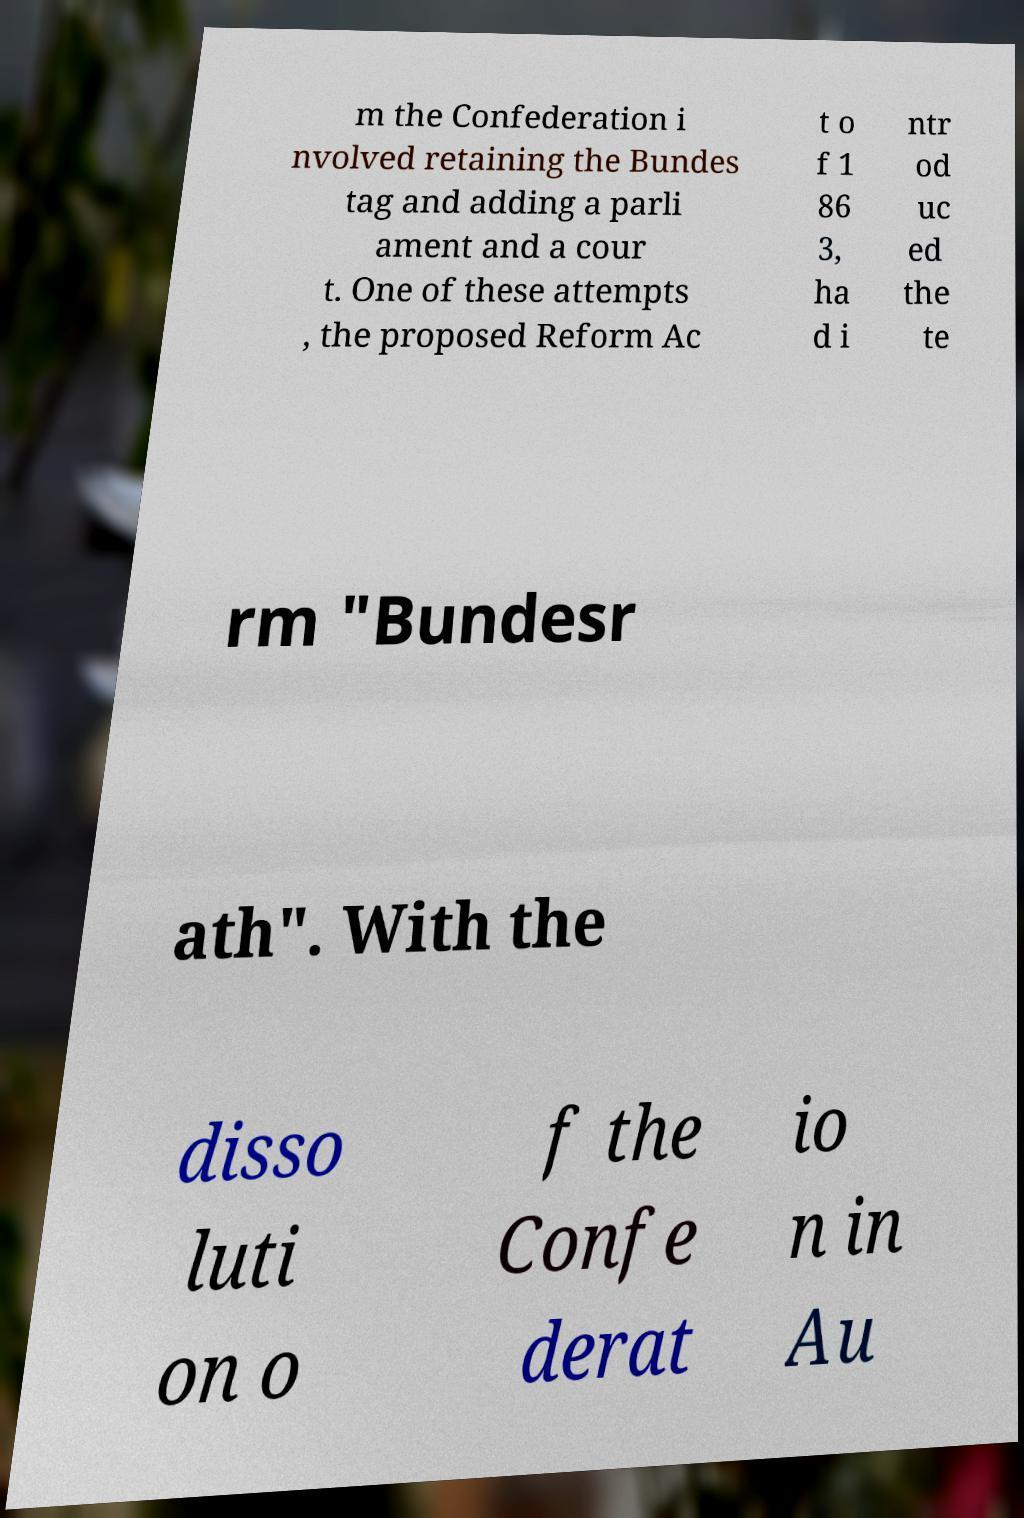Could you extract and type out the text from this image? m the Confederation i nvolved retaining the Bundes tag and adding a parli ament and a cour t. One of these attempts , the proposed Reform Ac t o f 1 86 3, ha d i ntr od uc ed the te rm "Bundesr ath". With the disso luti on o f the Confe derat io n in Au 